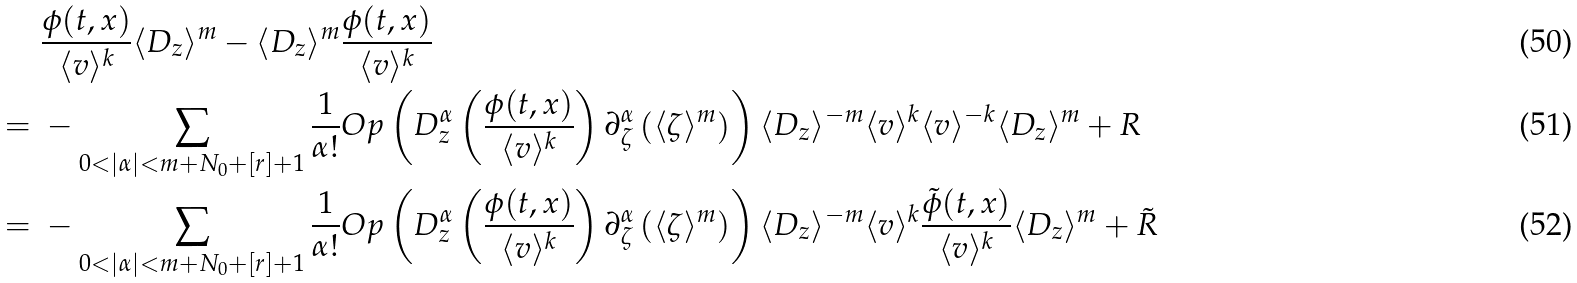<formula> <loc_0><loc_0><loc_500><loc_500>& \ \frac { \phi ( t , x ) } { \langle v \rangle ^ { k } } \langle D _ { z } \rangle ^ { m } - \langle D _ { z } \rangle ^ { m } \frac { \phi ( t , x ) } { \langle v \rangle ^ { k } } \\ = & \ - \sum _ { 0 < | \alpha | < m + N _ { 0 } + [ r ] + 1 } \frac { 1 } { \alpha ! } O p \left ( D _ { z } ^ { \alpha } \left ( \frac { \phi ( t , x ) } { \langle v \rangle ^ { k } } \right ) \partial _ { \zeta } ^ { \alpha } \left ( \langle \zeta \rangle ^ { m } \right ) \right ) \langle D _ { z } \rangle ^ { - m } \langle v \rangle ^ { k } \langle v \rangle ^ { - k } \langle D _ { z } \rangle ^ { m } + R \\ = & \ - \sum _ { 0 < | \alpha | < m + N _ { 0 } + [ r ] + 1 } \frac { 1 } { \alpha ! } O p \left ( D _ { z } ^ { \alpha } \left ( \frac { \phi ( t , x ) } { \langle v \rangle ^ { k } } \right ) \partial _ { \zeta } ^ { \alpha } \left ( \langle \zeta \rangle ^ { m } \right ) \right ) \langle D _ { z } \rangle ^ { - m } \langle v \rangle ^ { k } \frac { \tilde { \phi } ( t , x ) } { \langle v \rangle ^ { k } } \langle D _ { z } \rangle ^ { m } + \tilde { R }</formula> 